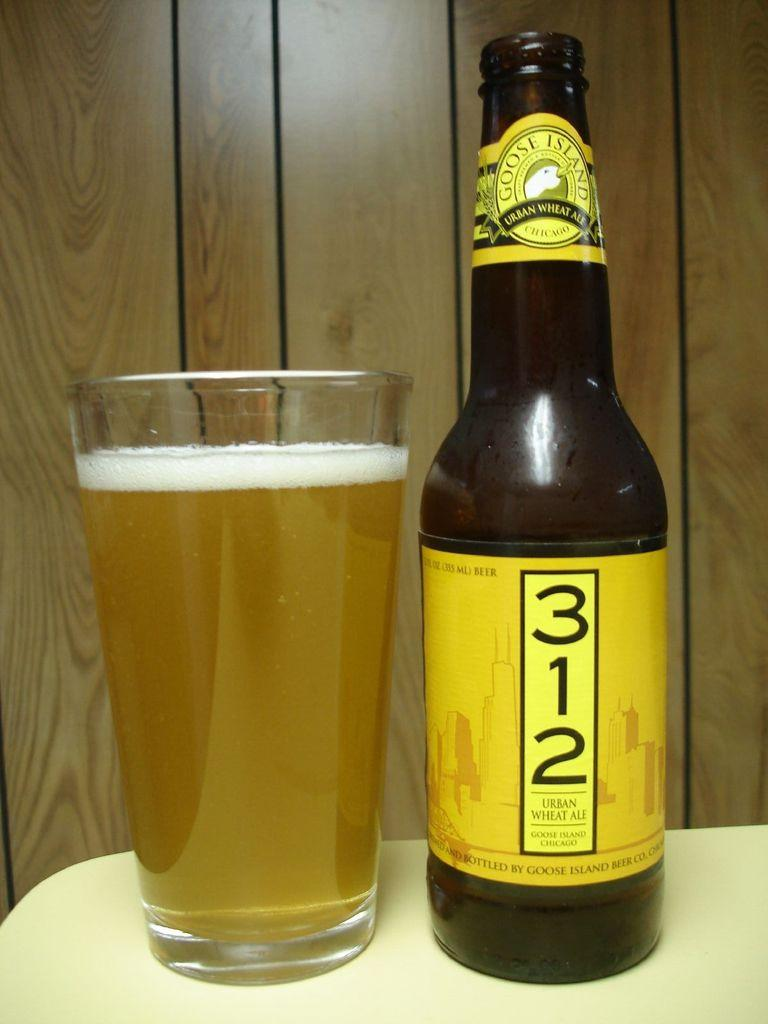<image>
Render a clear and concise summary of the photo. A bottle of Goose Island Urban Wheat Ale lies next to a glass of beer. 